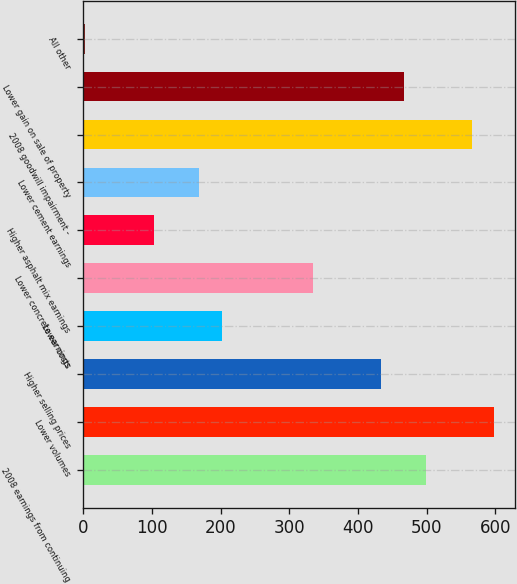Convert chart to OTSL. <chart><loc_0><loc_0><loc_500><loc_500><bar_chart><fcel>2008 earnings from continuing<fcel>Lower volumes<fcel>Higher selling prices<fcel>Lower costs<fcel>Lower concrete earnings<fcel>Higher asphalt mix earnings<fcel>Lower cement earnings<fcel>2008 goodwill impairment -<fcel>Lower gain on sale of property<fcel>All other<nl><fcel>499.15<fcel>598.42<fcel>432.97<fcel>201.34<fcel>333.7<fcel>102.07<fcel>168.25<fcel>565.33<fcel>466.06<fcel>2.8<nl></chart> 